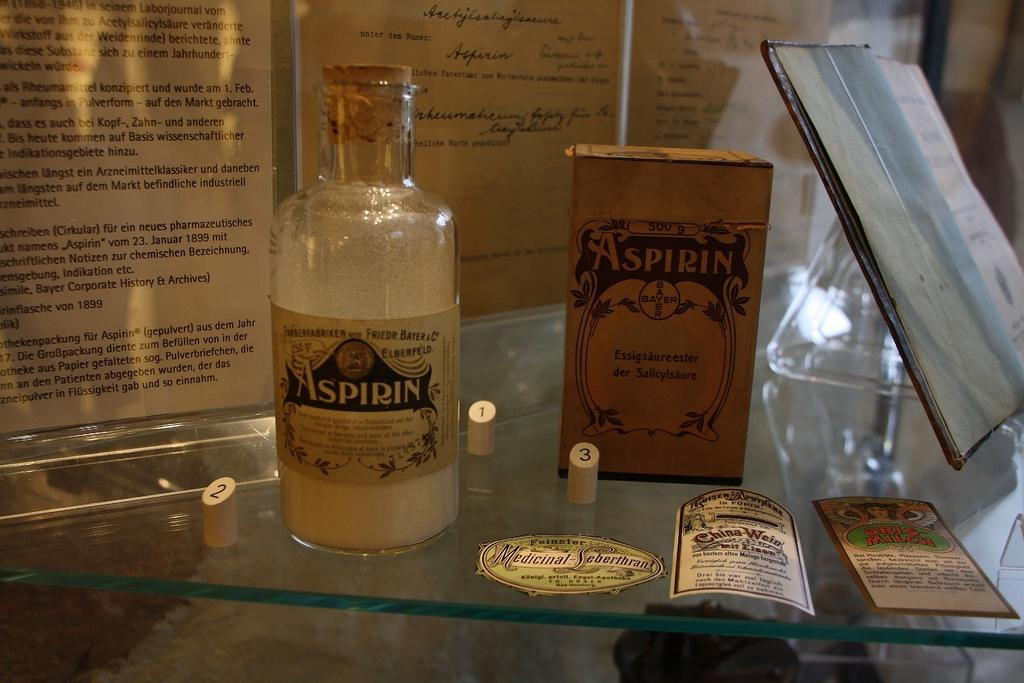<image>
Relay a brief, clear account of the picture shown. an old display of an Aspirin bottle and box from Bayer 